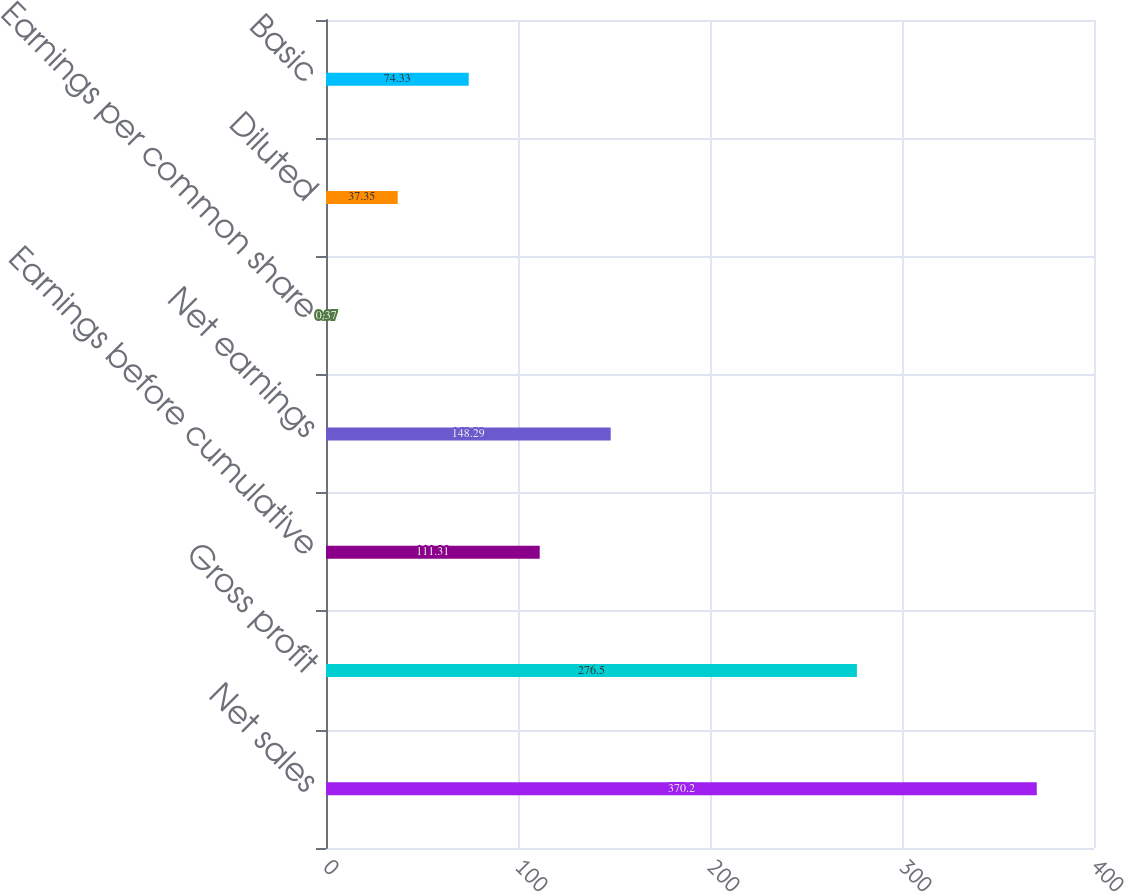Convert chart to OTSL. <chart><loc_0><loc_0><loc_500><loc_500><bar_chart><fcel>Net sales<fcel>Gross profit<fcel>Earnings before cumulative<fcel>Net earnings<fcel>Earnings per common share<fcel>Diluted<fcel>Basic<nl><fcel>370.2<fcel>276.5<fcel>111.31<fcel>148.29<fcel>0.37<fcel>37.35<fcel>74.33<nl></chart> 